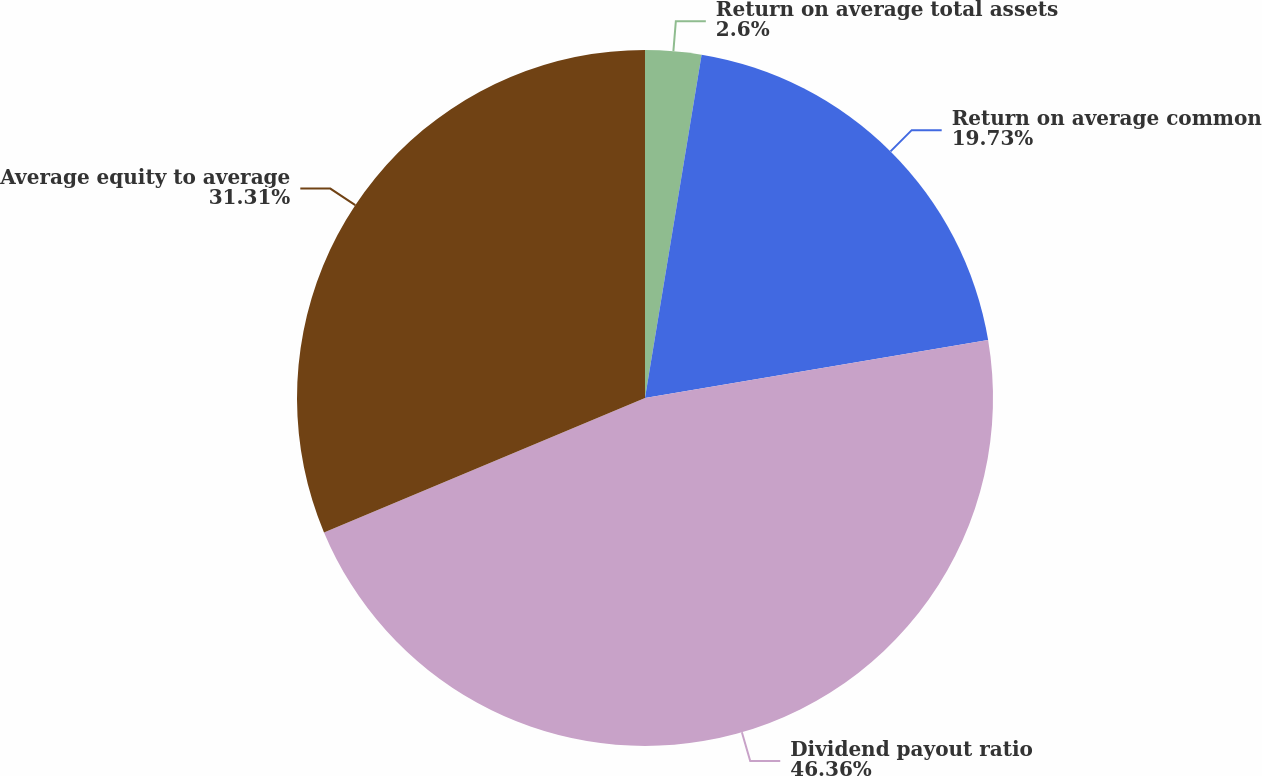Convert chart to OTSL. <chart><loc_0><loc_0><loc_500><loc_500><pie_chart><fcel>Return on average total assets<fcel>Return on average common<fcel>Dividend payout ratio<fcel>Average equity to average<nl><fcel>2.6%<fcel>19.73%<fcel>46.36%<fcel>31.31%<nl></chart> 